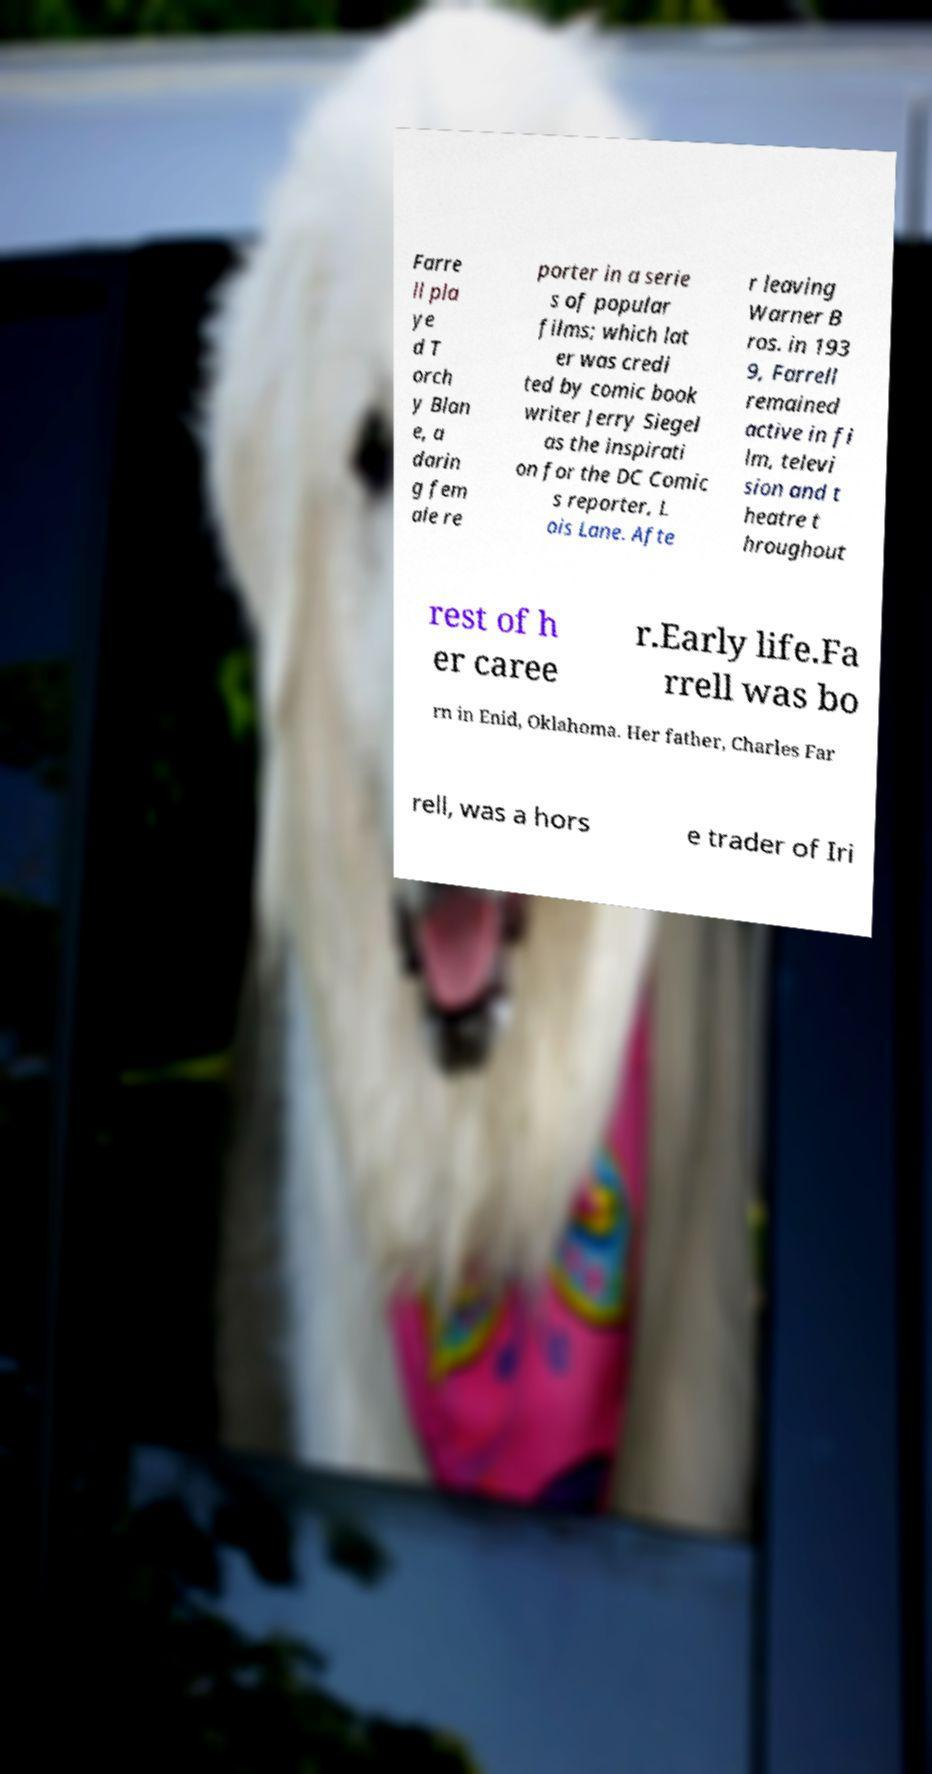Please identify and transcribe the text found in this image. Farre ll pla ye d T orch y Blan e, a darin g fem ale re porter in a serie s of popular films; which lat er was credi ted by comic book writer Jerry Siegel as the inspirati on for the DC Comic s reporter, L ois Lane. Afte r leaving Warner B ros. in 193 9, Farrell remained active in fi lm, televi sion and t heatre t hroughout rest of h er caree r.Early life.Fa rrell was bo rn in Enid, Oklahoma. Her father, Charles Far rell, was a hors e trader of Iri 